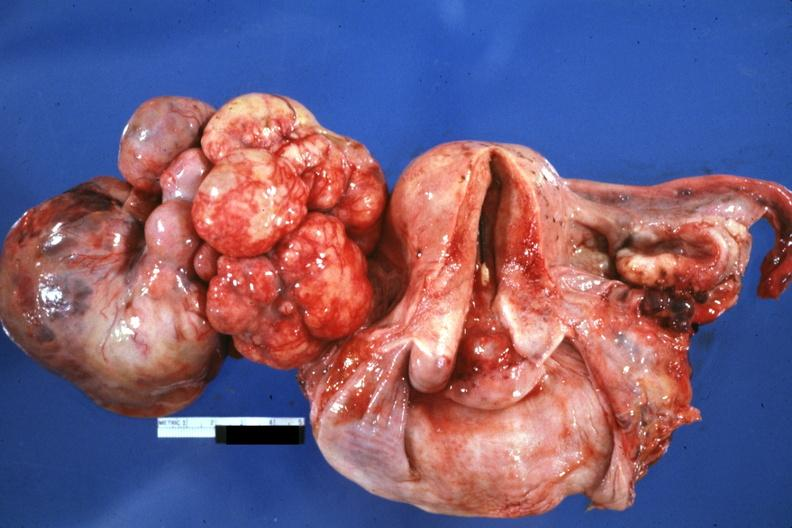s chromophobe adenoma present?
Answer the question using a single word or phrase. No 